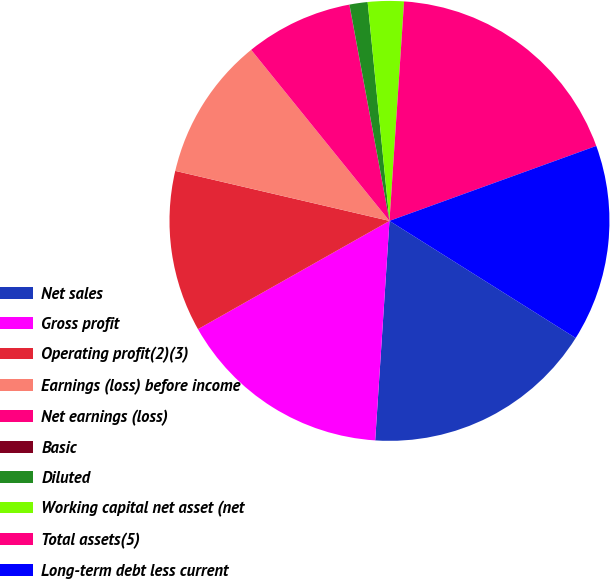<chart> <loc_0><loc_0><loc_500><loc_500><pie_chart><fcel>Net sales<fcel>Gross profit<fcel>Operating profit(2)(3)<fcel>Earnings (loss) before income<fcel>Net earnings (loss)<fcel>Basic<fcel>Diluted<fcel>Working capital net asset (net<fcel>Total assets(5)<fcel>Long-term debt less current<nl><fcel>17.1%<fcel>15.78%<fcel>11.84%<fcel>10.53%<fcel>7.9%<fcel>0.01%<fcel>1.33%<fcel>2.64%<fcel>18.41%<fcel>14.47%<nl></chart> 